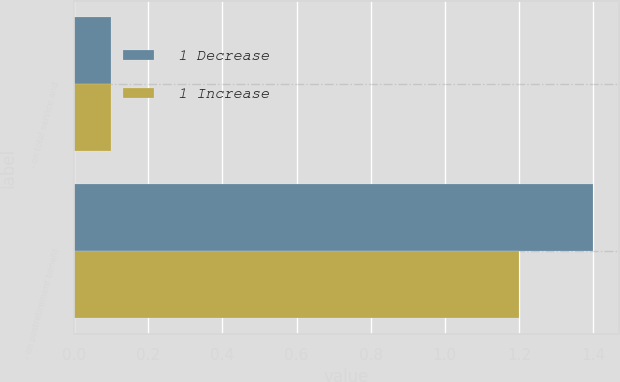Convert chart to OTSL. <chart><loc_0><loc_0><loc_500><loc_500><stacked_bar_chart><ecel><fcel>- on total service and<fcel>- on postretirement benefit<nl><fcel>1 Decrease<fcel>0.1<fcel>1.4<nl><fcel>1 Increase<fcel>0.1<fcel>1.2<nl></chart> 